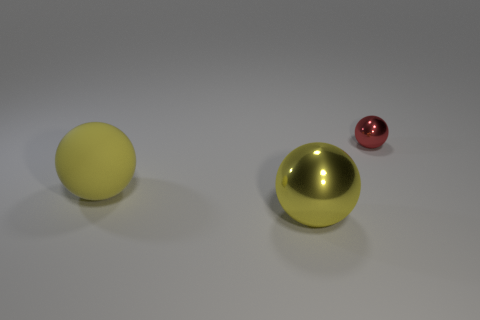Subtract all big matte balls. How many balls are left? 2 Add 1 small brown shiny balls. How many objects exist? 4 Subtract all red balls. How many balls are left? 2 Subtract all red blocks. How many brown spheres are left? 0 Subtract all large gray things. Subtract all small objects. How many objects are left? 2 Add 3 big objects. How many big objects are left? 5 Add 3 big brown matte spheres. How many big brown matte spheres exist? 3 Subtract 0 green cylinders. How many objects are left? 3 Subtract 1 balls. How many balls are left? 2 Subtract all brown spheres. Subtract all red cylinders. How many spheres are left? 3 